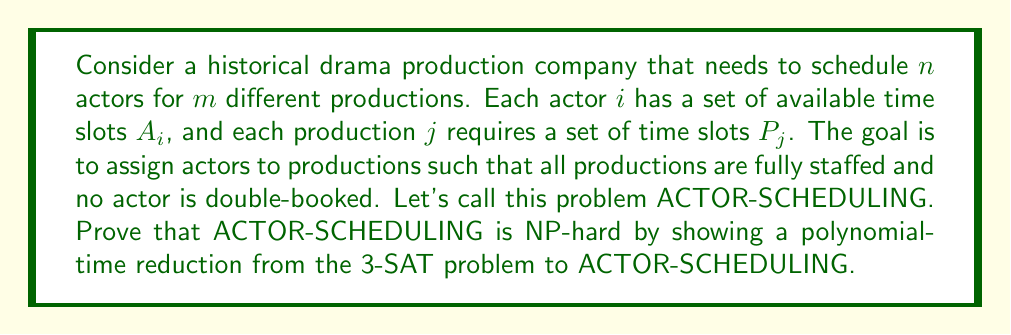Show me your answer to this math problem. To prove that ACTOR-SCHEDULING is NP-hard, we need to show that a known NP-complete problem can be reduced to it in polynomial time. We'll use the 3-SAT problem for this reduction.

1. 3-SAT Problem:
   Given a boolean formula in conjunctive normal form with 3 literals per clause, determine if there exists a satisfying assignment.

2. Reduction:
   We'll construct an instance of ACTOR-SCHEDULING from a 3-SAT instance.

   a) For each variable $x_i$ in the 3-SAT formula, create two actors: $a_{x_i}$ and $a_{\neg x_i}$.
   b) For each clause $C_j$ in the 3-SAT formula, create a production $P_j$.
   c) Create a time slot $t_i$ for each variable $x_i$.
   d) Set the available time slots for actors:
      - $A_{a_{x_i}} = \{t_i\}$
      - $A_{a_{\neg x_i}} = \{t_i\}$
   e) Set the required time slots for productions:
      - For each clause $C_j = (l_1 \vee l_2 \vee l_3)$, set $P_j = \{t_{i_1}, t_{i_2}, t_{i_3}\}$, where $t_{i_k}$ corresponds to the variable in literal $l_k$.

3. Correctness:
   - If the 3-SAT instance is satisfiable, then we can schedule actors for all productions:
     * For each true variable $x_i$, schedule $a_{x_i}$ at time $t_i$.
     * For each false variable $x_i$, schedule $a_{\neg x_i}$ at time $t_i$.
   - If ACTOR-SCHEDULING has a valid schedule, we can construct a satisfying assignment for 3-SAT:
     * If $a_{x_i}$ is scheduled, set $x_i$ to true.
     * If $a_{\neg x_i}$ is scheduled, set $x_i$ to false.

4. Polynomial-time:
   - The reduction creates $O(n)$ actors and $O(m)$ productions, where $n$ is the number of variables and $m$ is the number of clauses in the 3-SAT instance.
   - Each step of the reduction can be performed in polynomial time.

Therefore, we have shown a polynomial-time reduction from 3-SAT to ACTOR-SCHEDULING, proving that ACTOR-SCHEDULING is NP-hard.
Answer: ACTOR-SCHEDULING is NP-hard. 